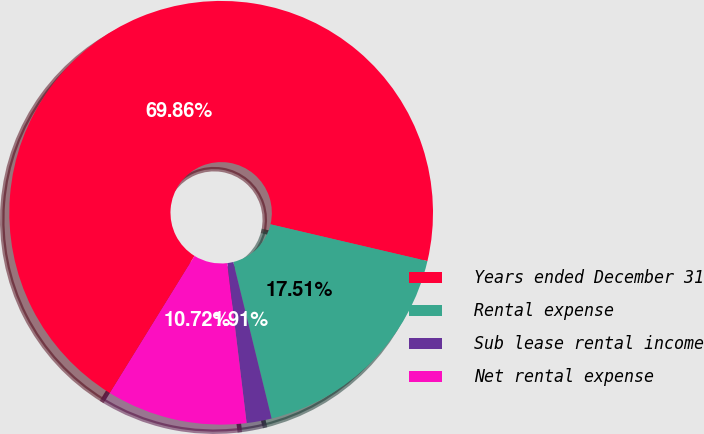Convert chart. <chart><loc_0><loc_0><loc_500><loc_500><pie_chart><fcel>Years ended December 31<fcel>Rental expense<fcel>Sub lease rental income<fcel>Net rental expense<nl><fcel>69.86%<fcel>17.51%<fcel>1.91%<fcel>10.72%<nl></chart> 